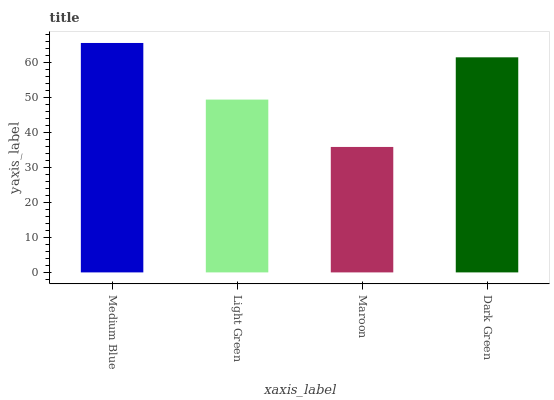Is Maroon the minimum?
Answer yes or no. Yes. Is Medium Blue the maximum?
Answer yes or no. Yes. Is Light Green the minimum?
Answer yes or no. No. Is Light Green the maximum?
Answer yes or no. No. Is Medium Blue greater than Light Green?
Answer yes or no. Yes. Is Light Green less than Medium Blue?
Answer yes or no. Yes. Is Light Green greater than Medium Blue?
Answer yes or no. No. Is Medium Blue less than Light Green?
Answer yes or no. No. Is Dark Green the high median?
Answer yes or no. Yes. Is Light Green the low median?
Answer yes or no. Yes. Is Maroon the high median?
Answer yes or no. No. Is Medium Blue the low median?
Answer yes or no. No. 